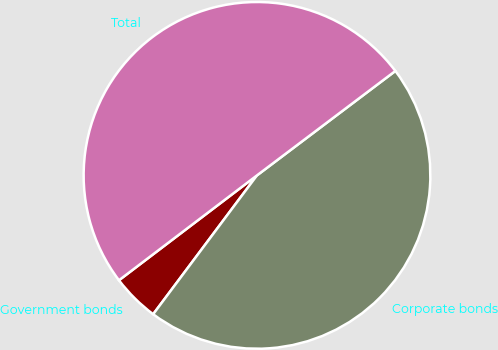Convert chart to OTSL. <chart><loc_0><loc_0><loc_500><loc_500><pie_chart><fcel>Government bonds<fcel>Corporate bonds<fcel>Total<nl><fcel>4.44%<fcel>45.51%<fcel>50.06%<nl></chart> 